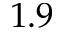<formula> <loc_0><loc_0><loc_500><loc_500>1 . 9</formula> 